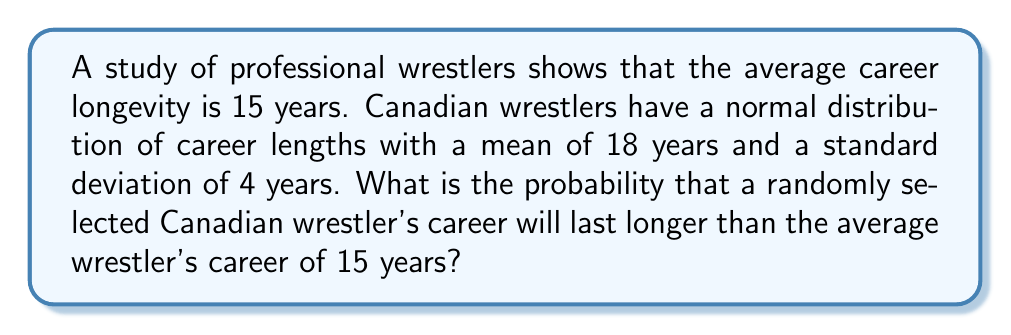Can you answer this question? Let's approach this step-by-step:

1) We're dealing with a normal distribution for Canadian wrestlers' career lengths:
   Mean (μ) = 18 years
   Standard deviation (σ) = 4 years

2) We want to find the probability of a career lasting longer than 15 years.

3) To do this, we need to calculate the z-score for 15 years:

   $$z = \frac{x - μ}{σ} = \frac{15 - 18}{4} = -0.75$$

4) Now, we need to find the probability of a z-score greater than -0.75.

5) Using a standard normal distribution table or calculator:
   P(Z > -0.75) = 1 - P(Z < -0.75) = 1 - 0.2266 = 0.7734

6) Therefore, the probability of a Canadian wrestler's career lasting longer than 15 years is approximately 0.7734 or 77.34%.
Answer: 0.7734 